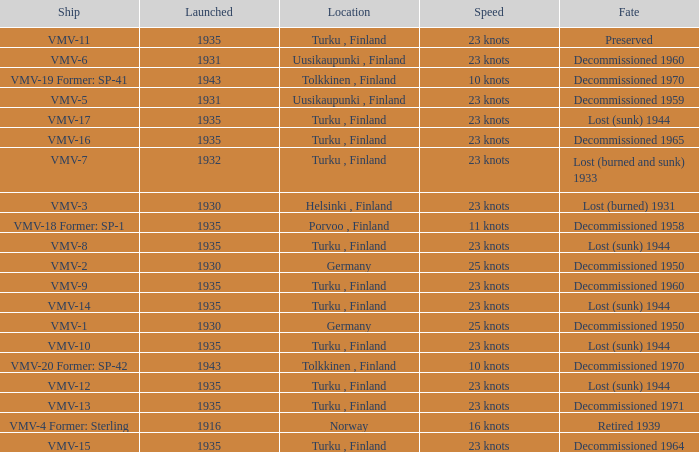What is the average launch date of the vmv-1 vessel in Germany? 1930.0. 